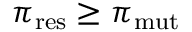Convert formula to latex. <formula><loc_0><loc_0><loc_500><loc_500>\pi _ { r e s } \geq \pi _ { m u t }</formula> 